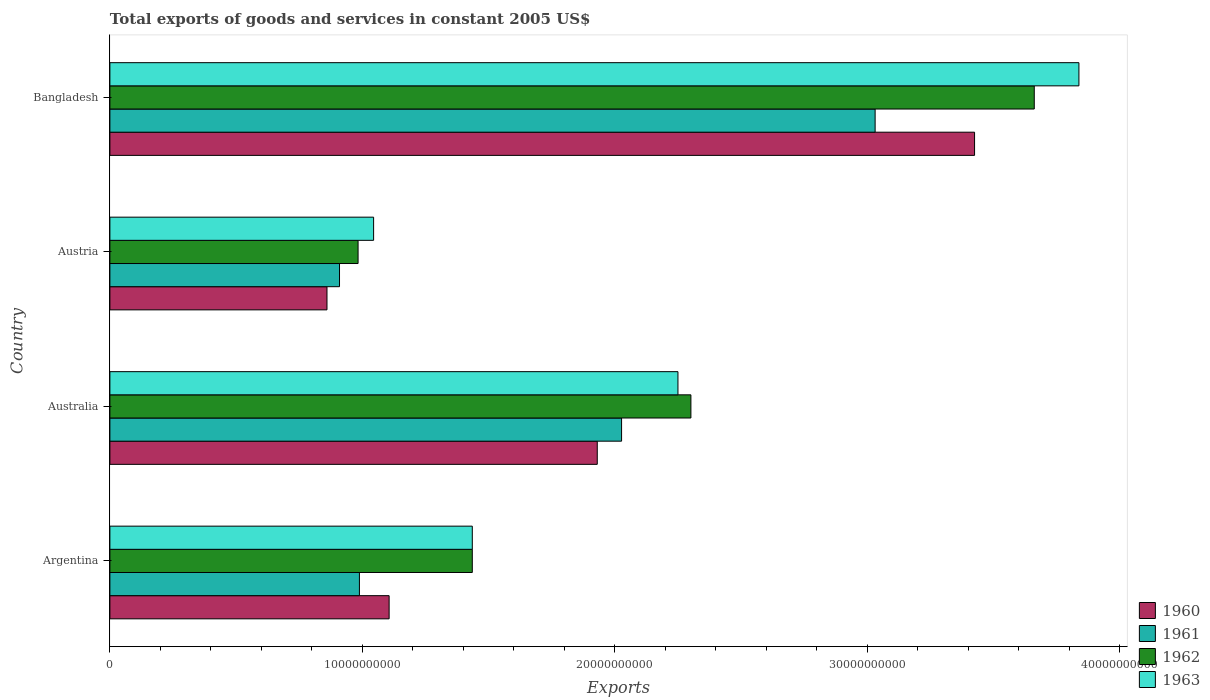How many different coloured bars are there?
Ensure brevity in your answer.  4. How many groups of bars are there?
Offer a very short reply. 4. How many bars are there on the 1st tick from the top?
Ensure brevity in your answer.  4. What is the label of the 4th group of bars from the top?
Offer a very short reply. Argentina. What is the total exports of goods and services in 1960 in Austria?
Your response must be concise. 8.60e+09. Across all countries, what is the maximum total exports of goods and services in 1963?
Offer a terse response. 3.84e+1. Across all countries, what is the minimum total exports of goods and services in 1962?
Provide a succinct answer. 9.83e+09. In which country was the total exports of goods and services in 1962 minimum?
Give a very brief answer. Austria. What is the total total exports of goods and services in 1960 in the graph?
Give a very brief answer. 7.32e+1. What is the difference between the total exports of goods and services in 1962 in Argentina and that in Australia?
Give a very brief answer. -8.66e+09. What is the difference between the total exports of goods and services in 1963 in Bangladesh and the total exports of goods and services in 1961 in Australia?
Offer a very short reply. 1.81e+1. What is the average total exports of goods and services in 1963 per country?
Offer a terse response. 2.14e+1. What is the difference between the total exports of goods and services in 1963 and total exports of goods and services in 1960 in Australia?
Offer a terse response. 3.20e+09. What is the ratio of the total exports of goods and services in 1963 in Australia to that in Austria?
Offer a very short reply. 2.15. Is the total exports of goods and services in 1960 in Argentina less than that in Australia?
Your response must be concise. Yes. Is the difference between the total exports of goods and services in 1963 in Austria and Bangladesh greater than the difference between the total exports of goods and services in 1960 in Austria and Bangladesh?
Your response must be concise. No. What is the difference between the highest and the second highest total exports of goods and services in 1960?
Your answer should be compact. 1.49e+1. What is the difference between the highest and the lowest total exports of goods and services in 1960?
Provide a short and direct response. 2.57e+1. Is the sum of the total exports of goods and services in 1963 in Australia and Bangladesh greater than the maximum total exports of goods and services in 1961 across all countries?
Offer a very short reply. Yes. Is it the case that in every country, the sum of the total exports of goods and services in 1962 and total exports of goods and services in 1961 is greater than the sum of total exports of goods and services in 1960 and total exports of goods and services in 1963?
Provide a succinct answer. No. Are all the bars in the graph horizontal?
Offer a terse response. Yes. How many countries are there in the graph?
Provide a succinct answer. 4. Does the graph contain grids?
Your answer should be very brief. No. Where does the legend appear in the graph?
Your answer should be compact. Bottom right. How many legend labels are there?
Ensure brevity in your answer.  4. What is the title of the graph?
Your answer should be very brief. Total exports of goods and services in constant 2005 US$. What is the label or title of the X-axis?
Your answer should be compact. Exports. What is the label or title of the Y-axis?
Give a very brief answer. Country. What is the Exports of 1960 in Argentina?
Offer a terse response. 1.11e+1. What is the Exports in 1961 in Argentina?
Provide a succinct answer. 9.88e+09. What is the Exports in 1962 in Argentina?
Your answer should be very brief. 1.44e+1. What is the Exports of 1963 in Argentina?
Provide a short and direct response. 1.44e+1. What is the Exports of 1960 in Australia?
Ensure brevity in your answer.  1.93e+1. What is the Exports in 1961 in Australia?
Your answer should be very brief. 2.03e+1. What is the Exports in 1962 in Australia?
Make the answer very short. 2.30e+1. What is the Exports of 1963 in Australia?
Ensure brevity in your answer.  2.25e+1. What is the Exports in 1960 in Austria?
Your response must be concise. 8.60e+09. What is the Exports in 1961 in Austria?
Make the answer very short. 9.10e+09. What is the Exports in 1962 in Austria?
Give a very brief answer. 9.83e+09. What is the Exports of 1963 in Austria?
Make the answer very short. 1.04e+1. What is the Exports in 1960 in Bangladesh?
Your response must be concise. 3.42e+1. What is the Exports of 1961 in Bangladesh?
Keep it short and to the point. 3.03e+1. What is the Exports of 1962 in Bangladesh?
Provide a succinct answer. 3.66e+1. What is the Exports in 1963 in Bangladesh?
Ensure brevity in your answer.  3.84e+1. Across all countries, what is the maximum Exports in 1960?
Provide a short and direct response. 3.42e+1. Across all countries, what is the maximum Exports of 1961?
Give a very brief answer. 3.03e+1. Across all countries, what is the maximum Exports of 1962?
Offer a terse response. 3.66e+1. Across all countries, what is the maximum Exports in 1963?
Give a very brief answer. 3.84e+1. Across all countries, what is the minimum Exports in 1960?
Provide a succinct answer. 8.60e+09. Across all countries, what is the minimum Exports in 1961?
Make the answer very short. 9.10e+09. Across all countries, what is the minimum Exports of 1962?
Offer a very short reply. 9.83e+09. Across all countries, what is the minimum Exports of 1963?
Give a very brief answer. 1.04e+1. What is the total Exports of 1960 in the graph?
Keep it short and to the point. 7.32e+1. What is the total Exports of 1961 in the graph?
Provide a short and direct response. 6.96e+1. What is the total Exports in 1962 in the graph?
Make the answer very short. 8.38e+1. What is the total Exports of 1963 in the graph?
Keep it short and to the point. 8.57e+1. What is the difference between the Exports of 1960 in Argentina and that in Australia?
Offer a very short reply. -8.24e+09. What is the difference between the Exports in 1961 in Argentina and that in Australia?
Your answer should be very brief. -1.04e+1. What is the difference between the Exports in 1962 in Argentina and that in Australia?
Offer a very short reply. -8.66e+09. What is the difference between the Exports of 1963 in Argentina and that in Australia?
Provide a short and direct response. -8.15e+09. What is the difference between the Exports of 1960 in Argentina and that in Austria?
Make the answer very short. 2.46e+09. What is the difference between the Exports in 1961 in Argentina and that in Austria?
Keep it short and to the point. 7.88e+08. What is the difference between the Exports of 1962 in Argentina and that in Austria?
Your answer should be very brief. 4.52e+09. What is the difference between the Exports in 1963 in Argentina and that in Austria?
Keep it short and to the point. 3.91e+09. What is the difference between the Exports in 1960 in Argentina and that in Bangladesh?
Provide a succinct answer. -2.32e+1. What is the difference between the Exports of 1961 in Argentina and that in Bangladesh?
Provide a short and direct response. -2.04e+1. What is the difference between the Exports of 1962 in Argentina and that in Bangladesh?
Offer a very short reply. -2.23e+1. What is the difference between the Exports in 1963 in Argentina and that in Bangladesh?
Provide a succinct answer. -2.40e+1. What is the difference between the Exports in 1960 in Australia and that in Austria?
Provide a short and direct response. 1.07e+1. What is the difference between the Exports in 1961 in Australia and that in Austria?
Offer a terse response. 1.12e+1. What is the difference between the Exports in 1962 in Australia and that in Austria?
Provide a short and direct response. 1.32e+1. What is the difference between the Exports of 1963 in Australia and that in Austria?
Ensure brevity in your answer.  1.21e+1. What is the difference between the Exports in 1960 in Australia and that in Bangladesh?
Offer a terse response. -1.49e+1. What is the difference between the Exports of 1961 in Australia and that in Bangladesh?
Offer a terse response. -1.00e+1. What is the difference between the Exports in 1962 in Australia and that in Bangladesh?
Provide a short and direct response. -1.36e+1. What is the difference between the Exports of 1963 in Australia and that in Bangladesh?
Ensure brevity in your answer.  -1.59e+1. What is the difference between the Exports of 1960 in Austria and that in Bangladesh?
Give a very brief answer. -2.57e+1. What is the difference between the Exports in 1961 in Austria and that in Bangladesh?
Offer a terse response. -2.12e+1. What is the difference between the Exports in 1962 in Austria and that in Bangladesh?
Provide a succinct answer. -2.68e+1. What is the difference between the Exports of 1963 in Austria and that in Bangladesh?
Offer a very short reply. -2.79e+1. What is the difference between the Exports in 1960 in Argentina and the Exports in 1961 in Australia?
Offer a very short reply. -9.21e+09. What is the difference between the Exports in 1960 in Argentina and the Exports in 1962 in Australia?
Provide a short and direct response. -1.20e+1. What is the difference between the Exports in 1960 in Argentina and the Exports in 1963 in Australia?
Keep it short and to the point. -1.14e+1. What is the difference between the Exports of 1961 in Argentina and the Exports of 1962 in Australia?
Your response must be concise. -1.31e+1. What is the difference between the Exports of 1961 in Argentina and the Exports of 1963 in Australia?
Provide a short and direct response. -1.26e+1. What is the difference between the Exports in 1962 in Argentina and the Exports in 1963 in Australia?
Ensure brevity in your answer.  -8.15e+09. What is the difference between the Exports in 1960 in Argentina and the Exports in 1961 in Austria?
Provide a succinct answer. 1.96e+09. What is the difference between the Exports of 1960 in Argentina and the Exports of 1962 in Austria?
Offer a terse response. 1.23e+09. What is the difference between the Exports of 1960 in Argentina and the Exports of 1963 in Austria?
Offer a terse response. 6.14e+08. What is the difference between the Exports in 1961 in Argentina and the Exports in 1962 in Austria?
Your answer should be compact. 5.33e+07. What is the difference between the Exports of 1961 in Argentina and the Exports of 1963 in Austria?
Offer a very short reply. -5.62e+08. What is the difference between the Exports in 1962 in Argentina and the Exports in 1963 in Austria?
Your answer should be compact. 3.91e+09. What is the difference between the Exports of 1960 in Argentina and the Exports of 1961 in Bangladesh?
Provide a short and direct response. -1.93e+1. What is the difference between the Exports of 1960 in Argentina and the Exports of 1962 in Bangladesh?
Your response must be concise. -2.56e+1. What is the difference between the Exports in 1960 in Argentina and the Exports in 1963 in Bangladesh?
Your response must be concise. -2.73e+1. What is the difference between the Exports of 1961 in Argentina and the Exports of 1962 in Bangladesh?
Provide a short and direct response. -2.67e+1. What is the difference between the Exports of 1961 in Argentina and the Exports of 1963 in Bangladesh?
Offer a very short reply. -2.85e+1. What is the difference between the Exports in 1962 in Argentina and the Exports in 1963 in Bangladesh?
Provide a succinct answer. -2.40e+1. What is the difference between the Exports in 1960 in Australia and the Exports in 1961 in Austria?
Offer a very short reply. 1.02e+1. What is the difference between the Exports of 1960 in Australia and the Exports of 1962 in Austria?
Your response must be concise. 9.47e+09. What is the difference between the Exports of 1960 in Australia and the Exports of 1963 in Austria?
Offer a very short reply. 8.86e+09. What is the difference between the Exports of 1961 in Australia and the Exports of 1962 in Austria?
Ensure brevity in your answer.  1.04e+1. What is the difference between the Exports in 1961 in Australia and the Exports in 1963 in Austria?
Provide a short and direct response. 9.82e+09. What is the difference between the Exports in 1962 in Australia and the Exports in 1963 in Austria?
Provide a succinct answer. 1.26e+1. What is the difference between the Exports in 1960 in Australia and the Exports in 1961 in Bangladesh?
Keep it short and to the point. -1.10e+1. What is the difference between the Exports in 1960 in Australia and the Exports in 1962 in Bangladesh?
Offer a terse response. -1.73e+1. What is the difference between the Exports of 1960 in Australia and the Exports of 1963 in Bangladesh?
Your response must be concise. -1.91e+1. What is the difference between the Exports in 1961 in Australia and the Exports in 1962 in Bangladesh?
Your answer should be very brief. -1.63e+1. What is the difference between the Exports in 1961 in Australia and the Exports in 1963 in Bangladesh?
Give a very brief answer. -1.81e+1. What is the difference between the Exports in 1962 in Australia and the Exports in 1963 in Bangladesh?
Make the answer very short. -1.54e+1. What is the difference between the Exports in 1960 in Austria and the Exports in 1961 in Bangladesh?
Your answer should be compact. -2.17e+1. What is the difference between the Exports in 1960 in Austria and the Exports in 1962 in Bangladesh?
Ensure brevity in your answer.  -2.80e+1. What is the difference between the Exports in 1960 in Austria and the Exports in 1963 in Bangladesh?
Offer a terse response. -2.98e+1. What is the difference between the Exports in 1961 in Austria and the Exports in 1962 in Bangladesh?
Provide a short and direct response. -2.75e+1. What is the difference between the Exports in 1961 in Austria and the Exports in 1963 in Bangladesh?
Ensure brevity in your answer.  -2.93e+1. What is the difference between the Exports in 1962 in Austria and the Exports in 1963 in Bangladesh?
Make the answer very short. -2.86e+1. What is the average Exports in 1960 per country?
Keep it short and to the point. 1.83e+1. What is the average Exports in 1961 per country?
Your answer should be compact. 1.74e+1. What is the average Exports in 1962 per country?
Your answer should be very brief. 2.10e+1. What is the average Exports of 1963 per country?
Make the answer very short. 2.14e+1. What is the difference between the Exports in 1960 and Exports in 1961 in Argentina?
Your answer should be very brief. 1.18e+09. What is the difference between the Exports in 1960 and Exports in 1962 in Argentina?
Provide a short and direct response. -3.29e+09. What is the difference between the Exports of 1960 and Exports of 1963 in Argentina?
Offer a terse response. -3.29e+09. What is the difference between the Exports of 1961 and Exports of 1962 in Argentina?
Make the answer very short. -4.47e+09. What is the difference between the Exports in 1961 and Exports in 1963 in Argentina?
Ensure brevity in your answer.  -4.47e+09. What is the difference between the Exports in 1960 and Exports in 1961 in Australia?
Offer a very short reply. -9.63e+08. What is the difference between the Exports in 1960 and Exports in 1962 in Australia?
Give a very brief answer. -3.71e+09. What is the difference between the Exports of 1960 and Exports of 1963 in Australia?
Provide a succinct answer. -3.20e+09. What is the difference between the Exports in 1961 and Exports in 1962 in Australia?
Your answer should be compact. -2.75e+09. What is the difference between the Exports of 1961 and Exports of 1963 in Australia?
Provide a succinct answer. -2.23e+09. What is the difference between the Exports in 1962 and Exports in 1963 in Australia?
Ensure brevity in your answer.  5.13e+08. What is the difference between the Exports of 1960 and Exports of 1961 in Austria?
Your response must be concise. -4.96e+08. What is the difference between the Exports of 1960 and Exports of 1962 in Austria?
Your answer should be very brief. -1.23e+09. What is the difference between the Exports of 1960 and Exports of 1963 in Austria?
Ensure brevity in your answer.  -1.85e+09. What is the difference between the Exports in 1961 and Exports in 1962 in Austria?
Your answer should be compact. -7.35e+08. What is the difference between the Exports in 1961 and Exports in 1963 in Austria?
Provide a succinct answer. -1.35e+09. What is the difference between the Exports in 1962 and Exports in 1963 in Austria?
Give a very brief answer. -6.16e+08. What is the difference between the Exports in 1960 and Exports in 1961 in Bangladesh?
Keep it short and to the point. 3.94e+09. What is the difference between the Exports of 1960 and Exports of 1962 in Bangladesh?
Keep it short and to the point. -2.36e+09. What is the difference between the Exports of 1960 and Exports of 1963 in Bangladesh?
Keep it short and to the point. -4.13e+09. What is the difference between the Exports in 1961 and Exports in 1962 in Bangladesh?
Provide a short and direct response. -6.30e+09. What is the difference between the Exports of 1961 and Exports of 1963 in Bangladesh?
Offer a very short reply. -8.07e+09. What is the difference between the Exports in 1962 and Exports in 1963 in Bangladesh?
Ensure brevity in your answer.  -1.77e+09. What is the ratio of the Exports of 1960 in Argentina to that in Australia?
Keep it short and to the point. 0.57. What is the ratio of the Exports of 1961 in Argentina to that in Australia?
Offer a very short reply. 0.49. What is the ratio of the Exports in 1962 in Argentina to that in Australia?
Make the answer very short. 0.62. What is the ratio of the Exports of 1963 in Argentina to that in Australia?
Provide a succinct answer. 0.64. What is the ratio of the Exports of 1960 in Argentina to that in Austria?
Your answer should be compact. 1.29. What is the ratio of the Exports in 1961 in Argentina to that in Austria?
Offer a terse response. 1.09. What is the ratio of the Exports of 1962 in Argentina to that in Austria?
Provide a short and direct response. 1.46. What is the ratio of the Exports of 1963 in Argentina to that in Austria?
Your response must be concise. 1.37. What is the ratio of the Exports of 1960 in Argentina to that in Bangladesh?
Provide a succinct answer. 0.32. What is the ratio of the Exports in 1961 in Argentina to that in Bangladesh?
Your answer should be compact. 0.33. What is the ratio of the Exports in 1962 in Argentina to that in Bangladesh?
Offer a terse response. 0.39. What is the ratio of the Exports of 1963 in Argentina to that in Bangladesh?
Your answer should be compact. 0.37. What is the ratio of the Exports in 1960 in Australia to that in Austria?
Your answer should be very brief. 2.25. What is the ratio of the Exports in 1961 in Australia to that in Austria?
Your answer should be compact. 2.23. What is the ratio of the Exports of 1962 in Australia to that in Austria?
Make the answer very short. 2.34. What is the ratio of the Exports of 1963 in Australia to that in Austria?
Offer a very short reply. 2.15. What is the ratio of the Exports of 1960 in Australia to that in Bangladesh?
Keep it short and to the point. 0.56. What is the ratio of the Exports of 1961 in Australia to that in Bangladesh?
Give a very brief answer. 0.67. What is the ratio of the Exports in 1962 in Australia to that in Bangladesh?
Make the answer very short. 0.63. What is the ratio of the Exports of 1963 in Australia to that in Bangladesh?
Provide a short and direct response. 0.59. What is the ratio of the Exports of 1960 in Austria to that in Bangladesh?
Your answer should be compact. 0.25. What is the ratio of the Exports of 1961 in Austria to that in Bangladesh?
Offer a very short reply. 0.3. What is the ratio of the Exports of 1962 in Austria to that in Bangladesh?
Your response must be concise. 0.27. What is the ratio of the Exports of 1963 in Austria to that in Bangladesh?
Ensure brevity in your answer.  0.27. What is the difference between the highest and the second highest Exports of 1960?
Keep it short and to the point. 1.49e+1. What is the difference between the highest and the second highest Exports in 1961?
Give a very brief answer. 1.00e+1. What is the difference between the highest and the second highest Exports of 1962?
Provide a succinct answer. 1.36e+1. What is the difference between the highest and the second highest Exports in 1963?
Keep it short and to the point. 1.59e+1. What is the difference between the highest and the lowest Exports of 1960?
Give a very brief answer. 2.57e+1. What is the difference between the highest and the lowest Exports in 1961?
Keep it short and to the point. 2.12e+1. What is the difference between the highest and the lowest Exports in 1962?
Your response must be concise. 2.68e+1. What is the difference between the highest and the lowest Exports in 1963?
Provide a succinct answer. 2.79e+1. 